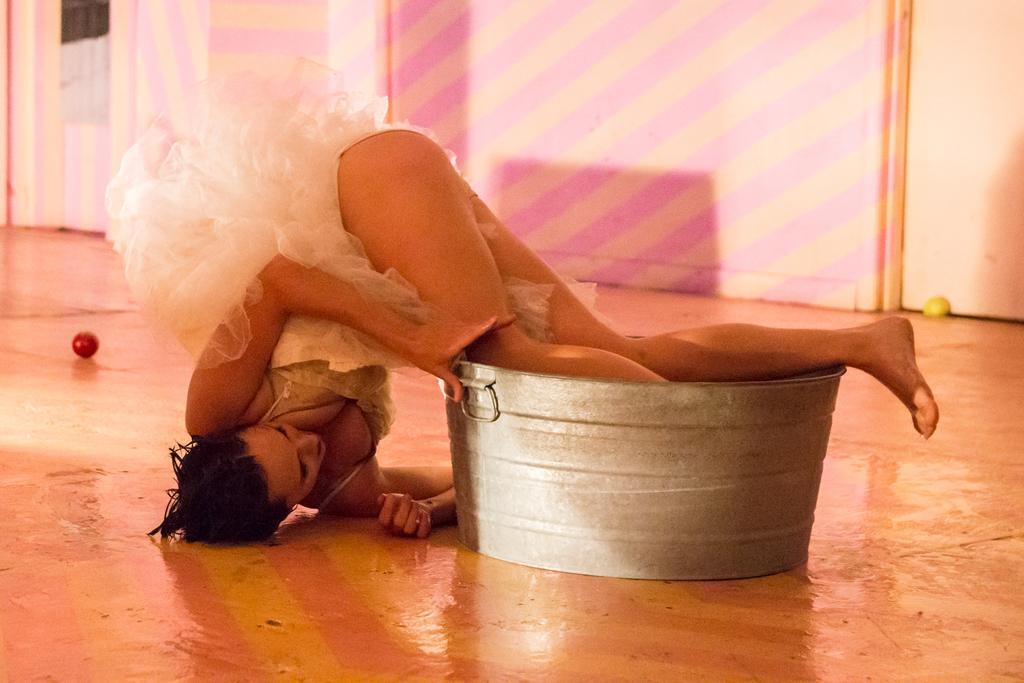Please provide a concise description of this image. In this image we can see a woman lying down on the floor keeping her legs in a container. We can also see a ball on the floor. On the backside we can see a wall. 